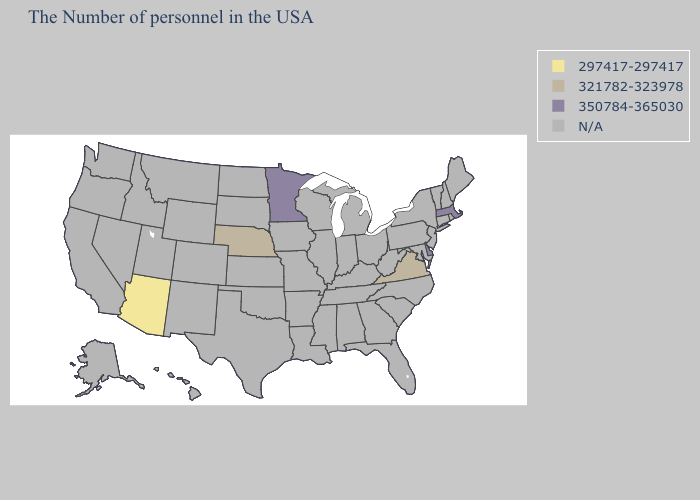Name the states that have a value in the range 321782-323978?
Be succinct. Virginia, Nebraska. What is the value of Montana?
Answer briefly. N/A. What is the value of Maine?
Write a very short answer. N/A. Does Minnesota have the highest value in the USA?
Give a very brief answer. Yes. Name the states that have a value in the range 297417-297417?
Quick response, please. Arizona. What is the value of Arkansas?
Be succinct. N/A. Among the states that border Nevada , which have the highest value?
Be succinct. Arizona. Which states have the highest value in the USA?
Keep it brief. Massachusetts, Delaware, Minnesota. What is the value of Indiana?
Answer briefly. N/A. Name the states that have a value in the range 350784-365030?
Write a very short answer. Massachusetts, Delaware, Minnesota. What is the value of New York?
Concise answer only. N/A. Is the legend a continuous bar?
Be succinct. No. Does the map have missing data?
Concise answer only. Yes. Name the states that have a value in the range 297417-297417?
Quick response, please. Arizona. 